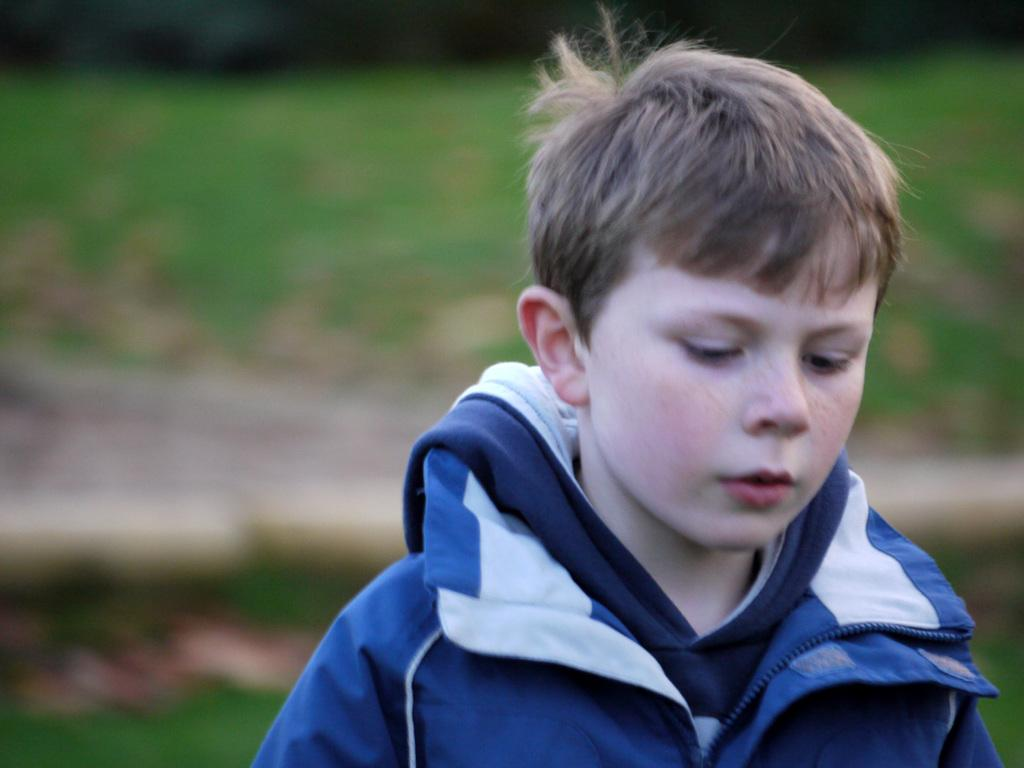What is the main subject of the image? There is a boy in the image. Can you describe the background of the image? The background of the image is blurred. What type of crime is the boy committing in the image? There is no indication of any crime being committed in the image; it simply features a boy with a blurred background. Can you tell me how many aunts the boy has in the image? There is no mention of any family members, including aunts, in the image. 